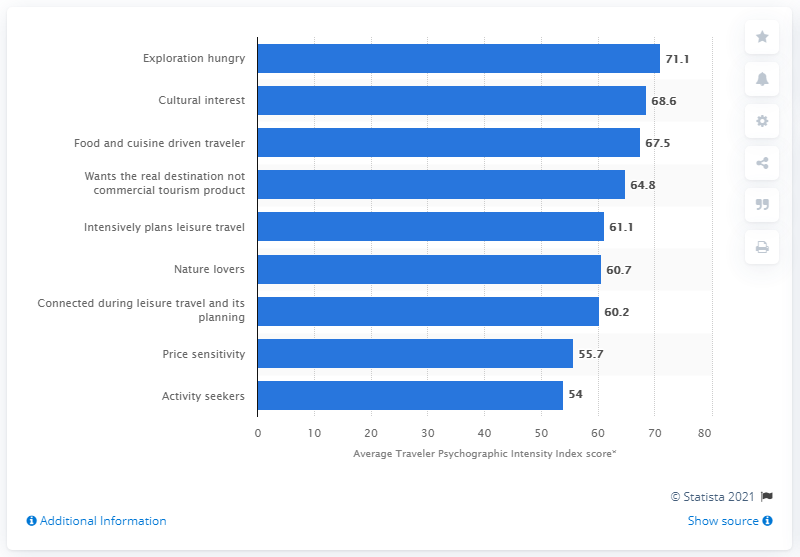Point out several critical features in this image. The average score for the Traveler Psychographic Intensity Index among Generation X travelers was 71.1. 